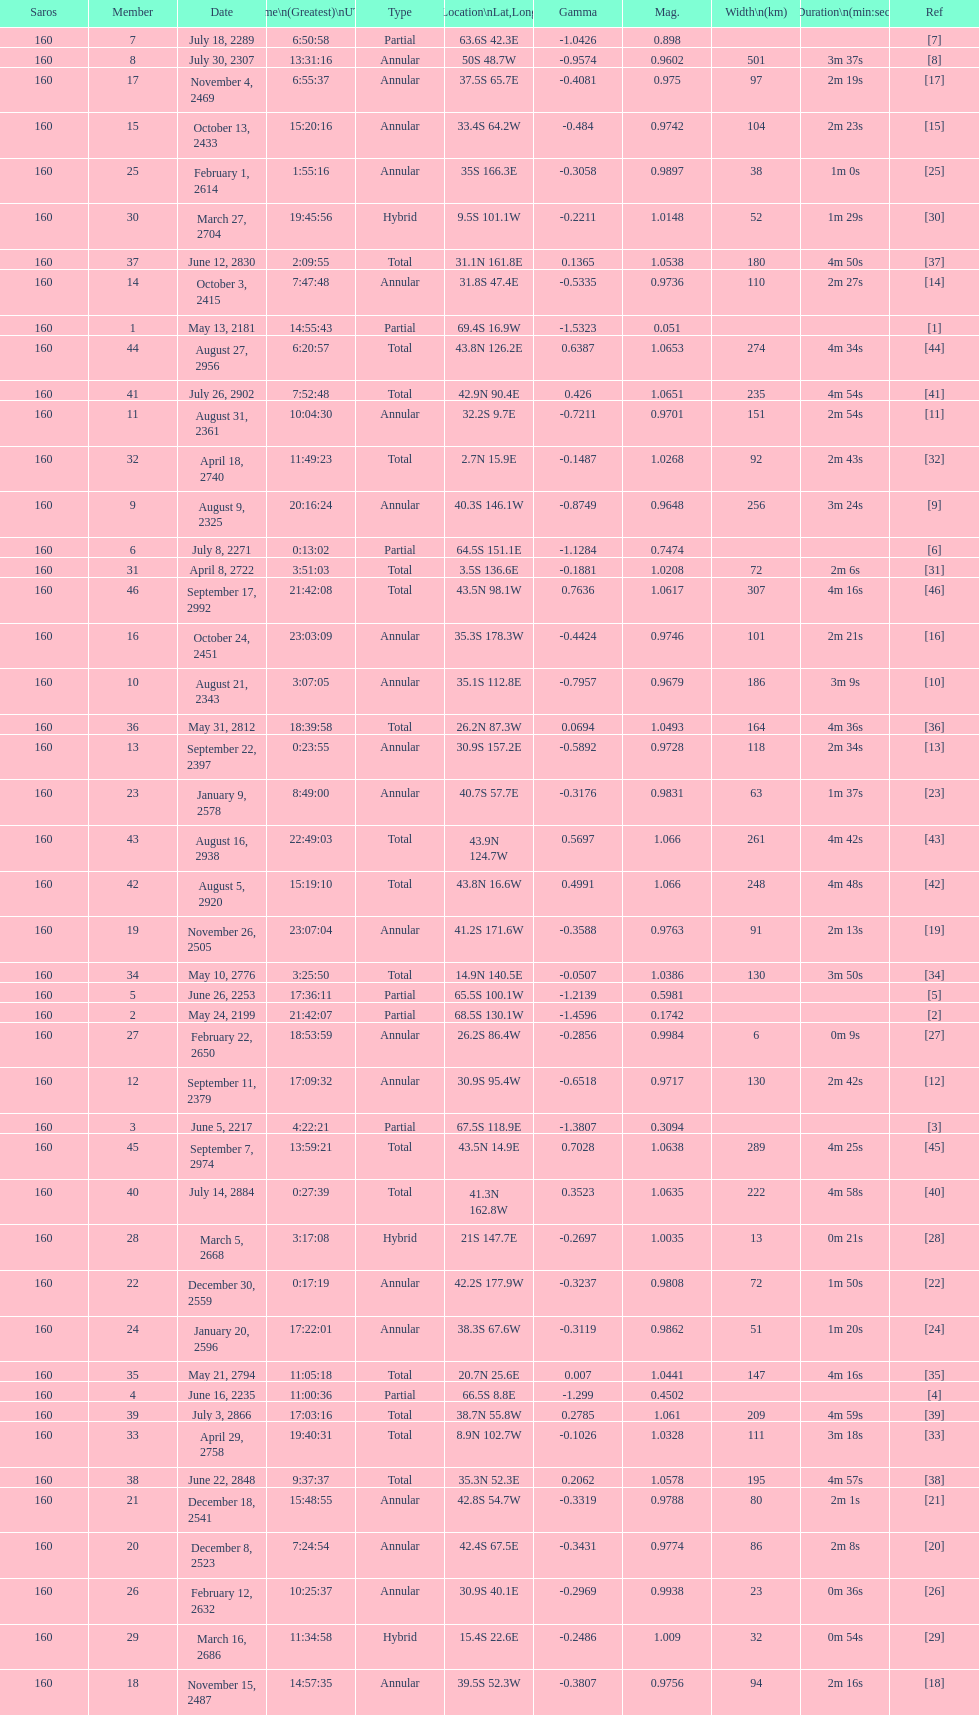What is the difference in magnitude between the may 13, 2181 solar saros and the may 24, 2199 solar saros? 0.1232. 